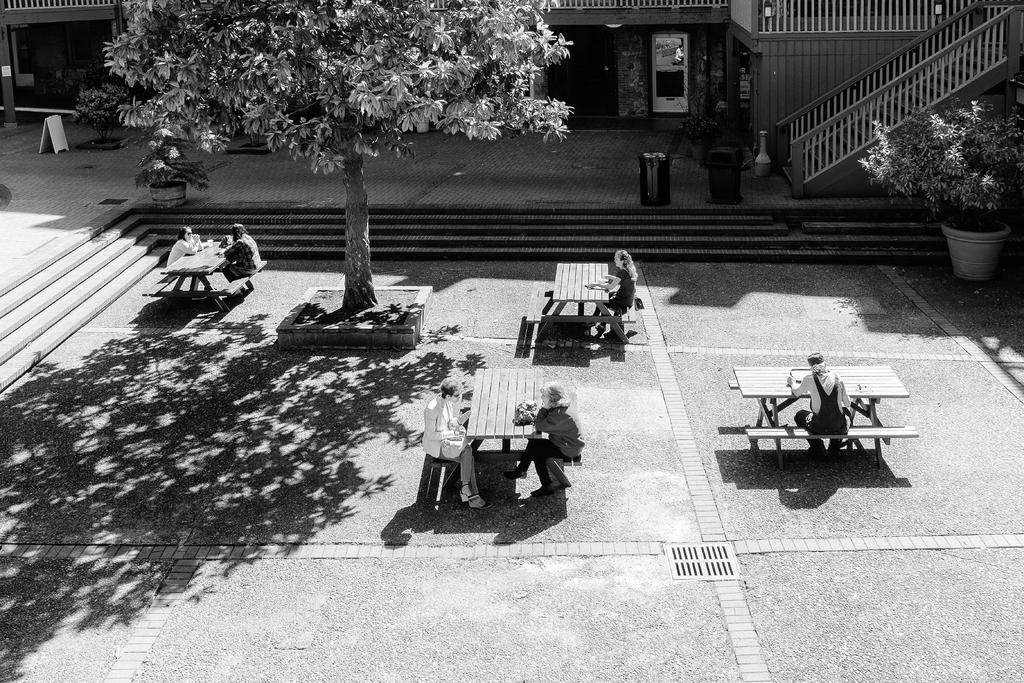How many people are in the image? There is a group of people in the image, but the exact number cannot be determined from the provided facts. What are the people doing in the image? The people are sitting on chairs in the image. Where are the chairs located in relation to the table? The chairs are in front of a table in the image. What is the table resting on? The table is on the floor in the image. What type of vegetation can be seen in the image? There is a tree and a plant in the image. Are there any architectural features in the image? Yes, there are stairs in the image. What type of ice can be seen melting on the table in the image? There is no ice present in the image; it features a group of people sitting on chairs in front of a table. 